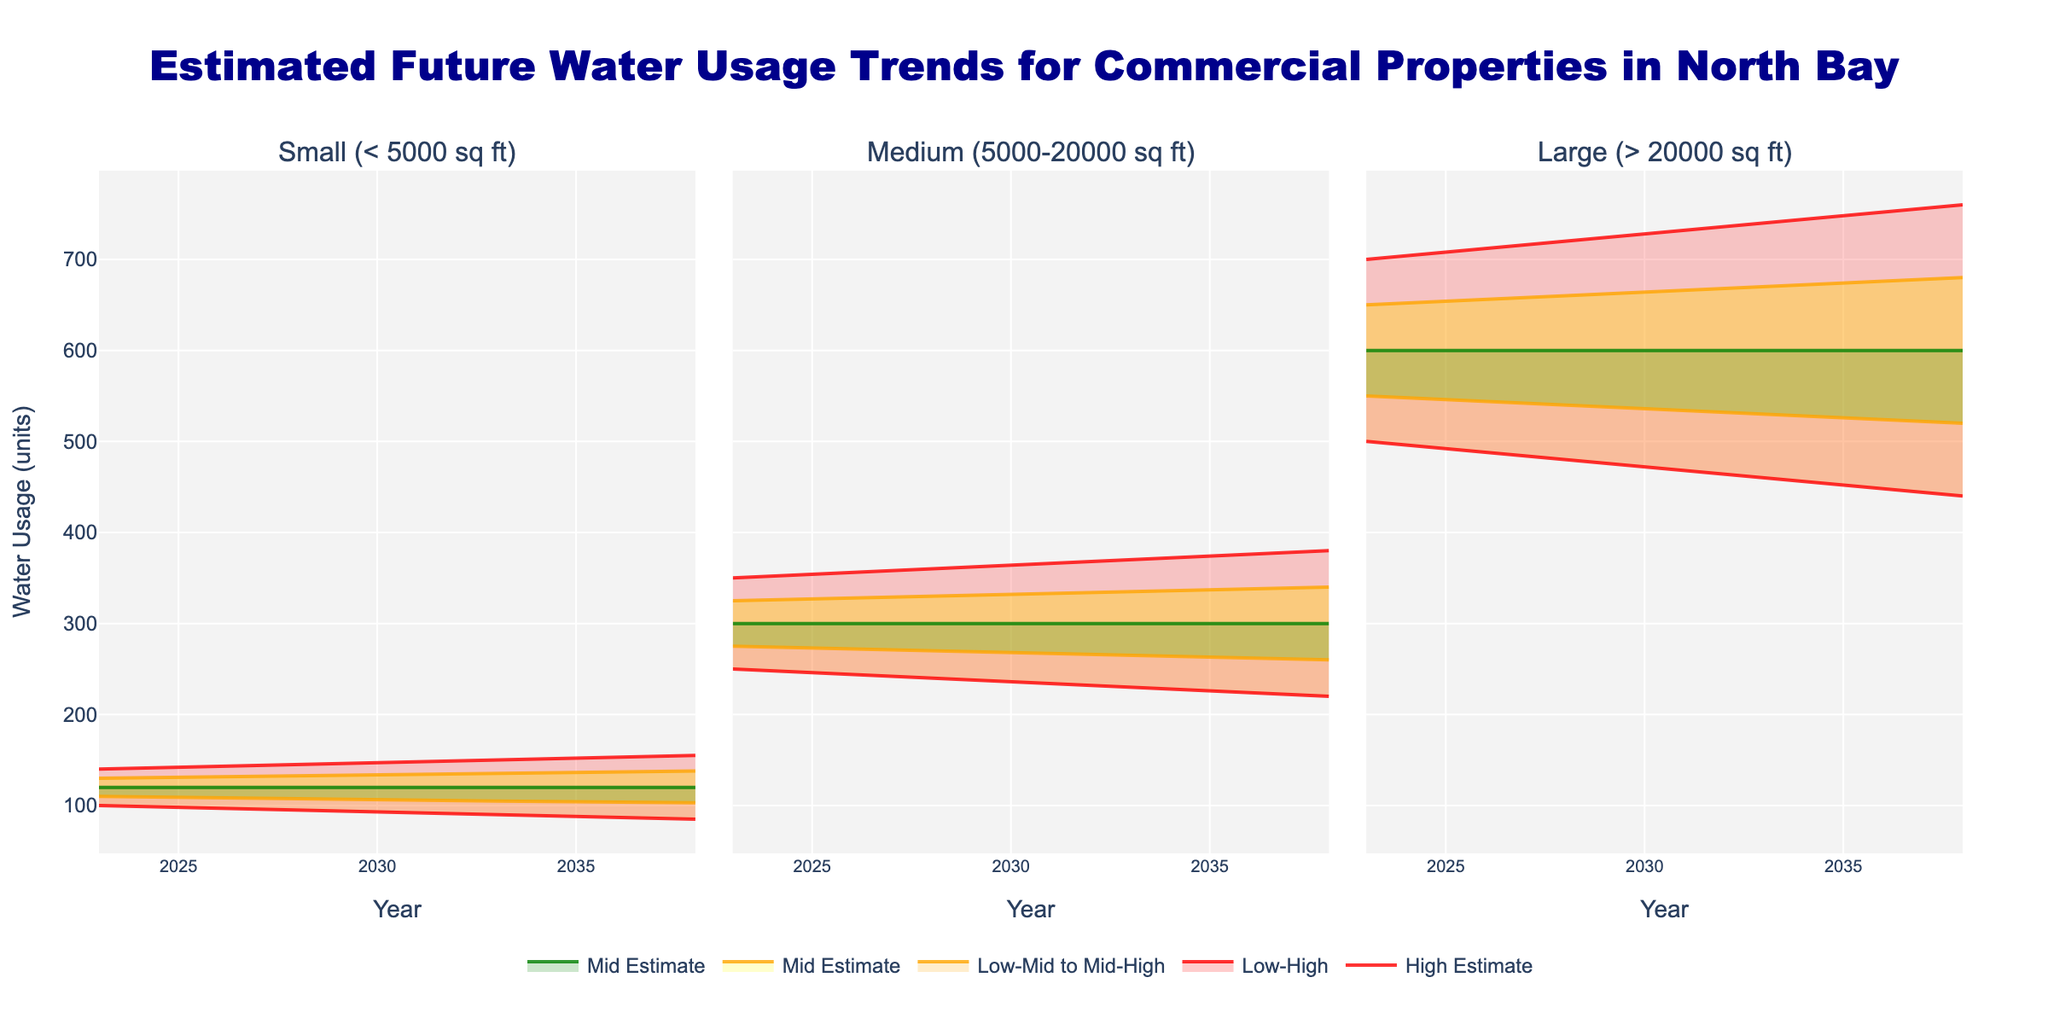What's the title of the chart? The title is prominently displayed at the top of the chart. It summarizes the main message of the chart, which is related to estimated water usage trends for commercial properties in North Bay.
Answer: Estimated Future Water Usage Trends for Commercial Properties in North Bay How many property sizes are included in the chart? By looking at the three subplots, each displaying data for different property sizes, we can count the different categories.
Answer: 3 What does the green shaded area represent? The green shaded area corresponds to the "Mid Estimate" range. It indicates the central tendency of the estimated water usage between the low-mid and mid-high values for each year.
Answer: Mid Estimate What is the estimated water usage for small properties in 2028 according to the high estimate? By looking at the plot's high estimate line (typically the outermost line) for small properties in 2028, we find the value.
Answer: 145 units Which property size has the highest mid estimate of water usage in 2033? Comparing the mid estimates for each property size in the plot for the year 2033, we can find that the large properties have the highest mid estimate.
Answer: Large Is the estimated water usage for medium properties expected to increase or decrease over time? By observing the trend of the mid estimate line for medium properties from 2023 to 2038, we see it remains constant.
Answer: Remain constant How does the high estimate for water usage in 2028 for large properties compare to the high estimate in 2023? By checking the high estimate lines for 2028 and 2023 in the large properties subplot, we note that in 2023 it is 700 units and in 2028 it is 720 units.
Answer: Increased What is the difference between the high estimate and low estimate for large properties in 2038? Looking at the high and low estimate values for large properties in 2038: high is 760 units, low is 440 units. Calculating the difference: 760 - 440 = 320 units.
Answer: 320 units What trend is visible for small properties’ water usage over the years? Checking the overall mid estimate trend for small properties, it shows a slight decrease over time.
Answer: Decreasing What’s the range of the low estimates for medium properties from 2023 to 2038? Observing the low estimate values for medium properties over the given years: 2023 is 250, 2028 is 240, 2033 is 230, and 2038 is 220. The range is from 220 to 250.
Answer: 220 to 250 